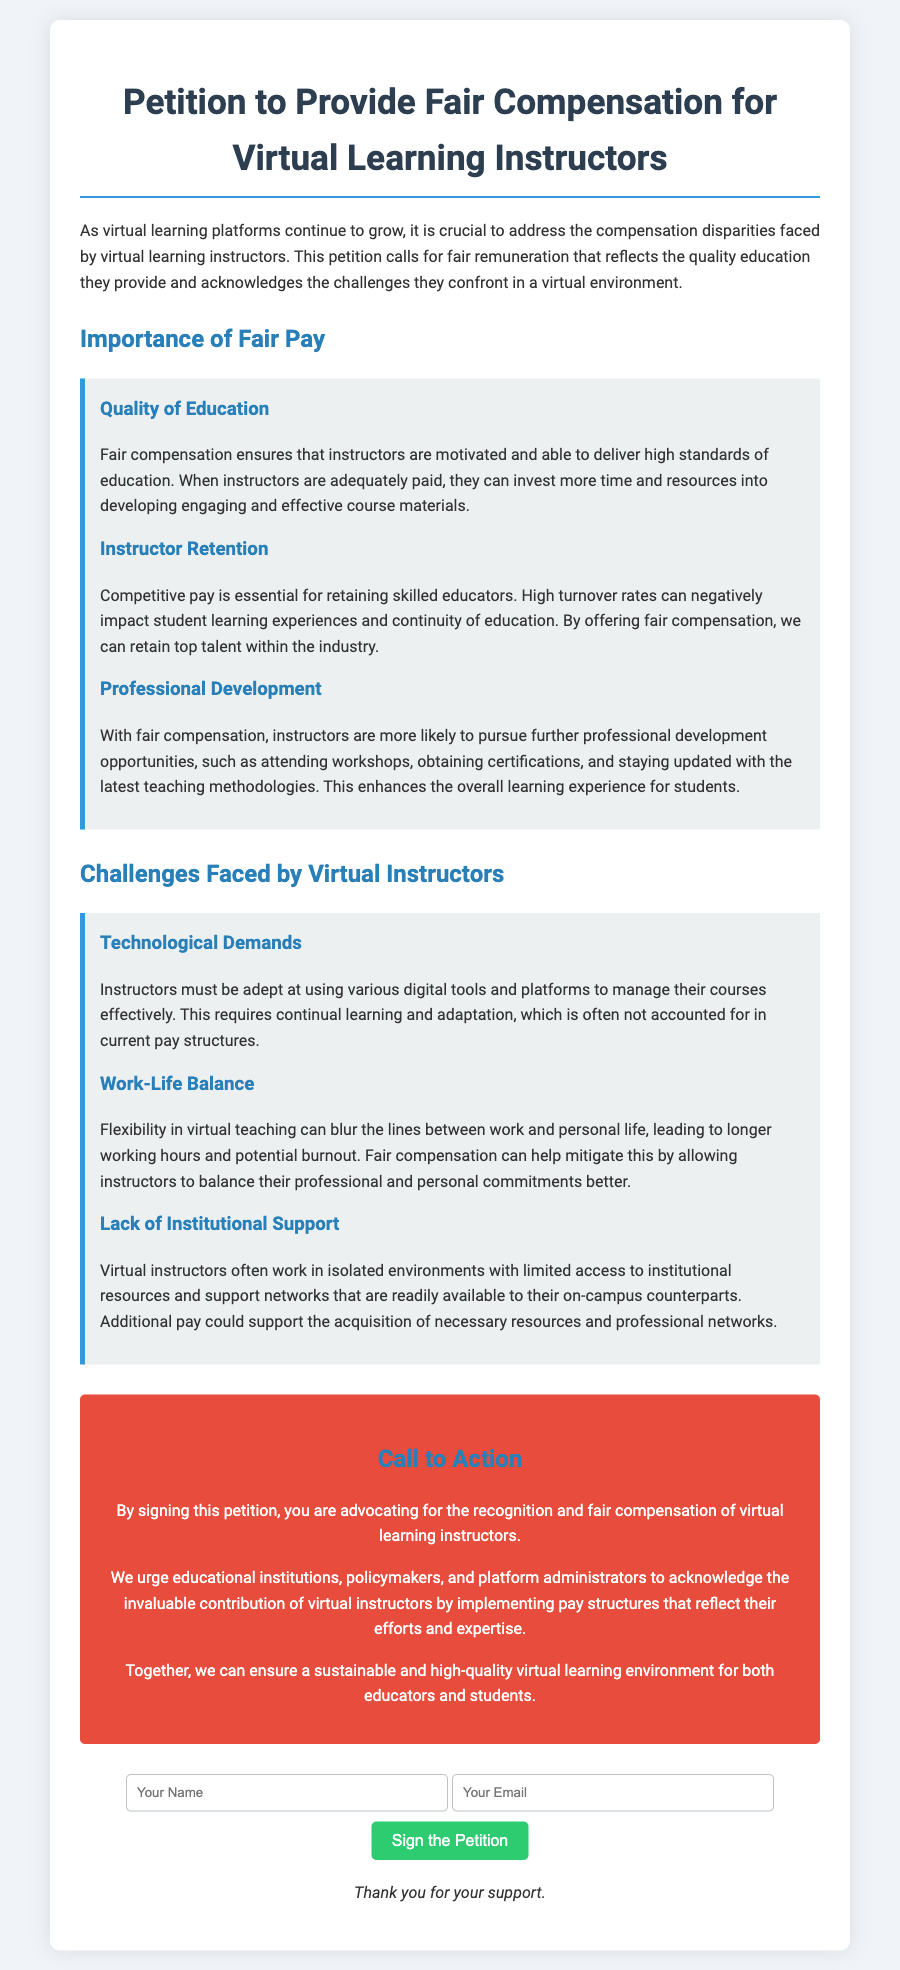What is the title of the petition? The title of the petition is the main heading that indicates its purpose.
Answer: Petition to Provide Fair Compensation for Virtual Learning Instructors What is one reason for fair pay mentioned in the document? The document lists several reasons under the importance of fair pay section.
Answer: Quality of Education How does fair pay affect instructor retention? The document states that competitive pay is essential for retaining skilled educators.
Answer: High turnover rates What challenge do virtual instructors face regarding technological demands? The document explains the necessity for continual learning and adaptation to various digital tools.
Answer: Continual learning What is one suggested way to mitigate work-life balance issues for instructors? The document highlights that fair compensation can help instructors balance professional and personal commitments better.
Answer: Fair compensation How does the petition suggest supporting virtual instructors? The petition urges for the implementation of pay structures that reflect instructors' efforts and expertise.
Answer: Implementing pay structures How can individuals support the petition? The document invites individuals to advocate by signing the petition.
Answer: By signing the petition What color is used for the call to action section? The document details the design elements of each section, including colors.
Answer: Red What is the format for submitting a signature? The document specifies the input areas required for signing.
Answer: Name and Email 